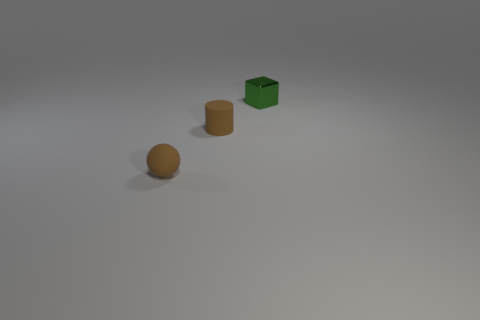What number of things are small matte balls or small green things? In the image, there are a total of three items; however, only one of them fits the description of being a small matte ball, which is the object with a spherical shape, and there is one small green thing, which is the cube. So to answer your question, there is one small matte ball and one small green thing, making the total count two as identified in the given response. 